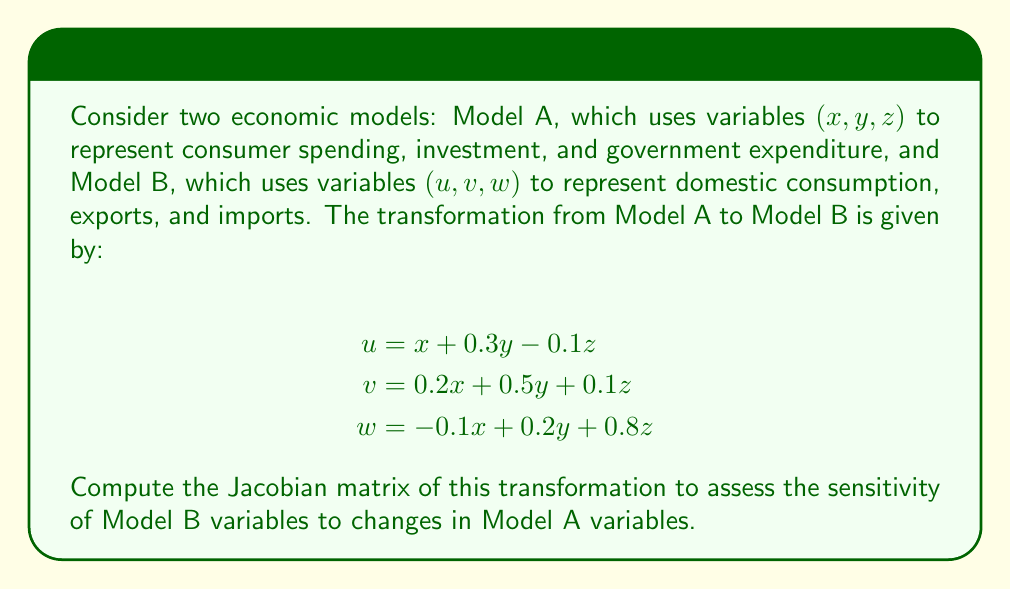Could you help me with this problem? To compute the Jacobian matrix, we need to calculate the partial derivatives of each variable in Model B with respect to each variable in Model A. The Jacobian matrix will have dimensions 3x3, as we have three variables in each model.

Let's calculate each element of the Jacobian matrix:

1. Partial derivatives of $u$:
   $$\frac{\partial u}{\partial x} = 1$$
   $$\frac{\partial u}{\partial y} = 0.3$$
   $$\frac{\partial u}{\partial z} = -0.1$$

2. Partial derivatives of $v$:
   $$\frac{\partial v}{\partial x} = 0.2$$
   $$\frac{\partial v}{\partial y} = 0.5$$
   $$\frac{\partial v}{\partial z} = 0.1$$

3. Partial derivatives of $w$:
   $$\frac{\partial w}{\partial x} = -0.1$$
   $$\frac{\partial w}{\partial y} = 0.2$$
   $$\frac{\partial w}{\partial z} = 0.8$$

Now, we can arrange these partial derivatives into the Jacobian matrix:

$$J = \begin{bmatrix}
\frac{\partial u}{\partial x} & \frac{\partial u}{\partial y} & \frac{\partial u}{\partial z} \\
\frac{\partial v}{\partial x} & \frac{\partial v}{\partial y} & \frac{\partial v}{\partial z} \\
\frac{\partial w}{\partial x} & \frac{\partial w}{\partial y} & \frac{\partial w}{\partial z}
\end{bmatrix}$$

Substituting the calculated values:

$$J = \begin{bmatrix}
1 & 0.3 & -0.1 \\
0.2 & 0.5 & 0.1 \\
-0.1 & 0.2 & 0.8
\end{bmatrix}$$

This Jacobian matrix represents the sensitivity of Model B variables to changes in Model A variables. Each element $(i,j)$ shows how a small change in the $j$-th variable of Model A affects the $i$-th variable of Model B.
Answer: $$J = \begin{bmatrix}
1 & 0.3 & -0.1 \\
0.2 & 0.5 & 0.1 \\
-0.1 & 0.2 & 0.8
\end{bmatrix}$$ 